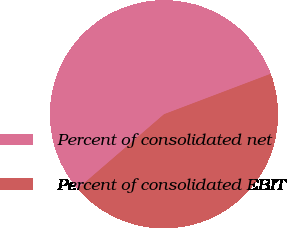Convert chart. <chart><loc_0><loc_0><loc_500><loc_500><pie_chart><fcel>Percent of consolidated net<fcel>Percent of consolidated EBIT<nl><fcel>55.56%<fcel>44.44%<nl></chart> 